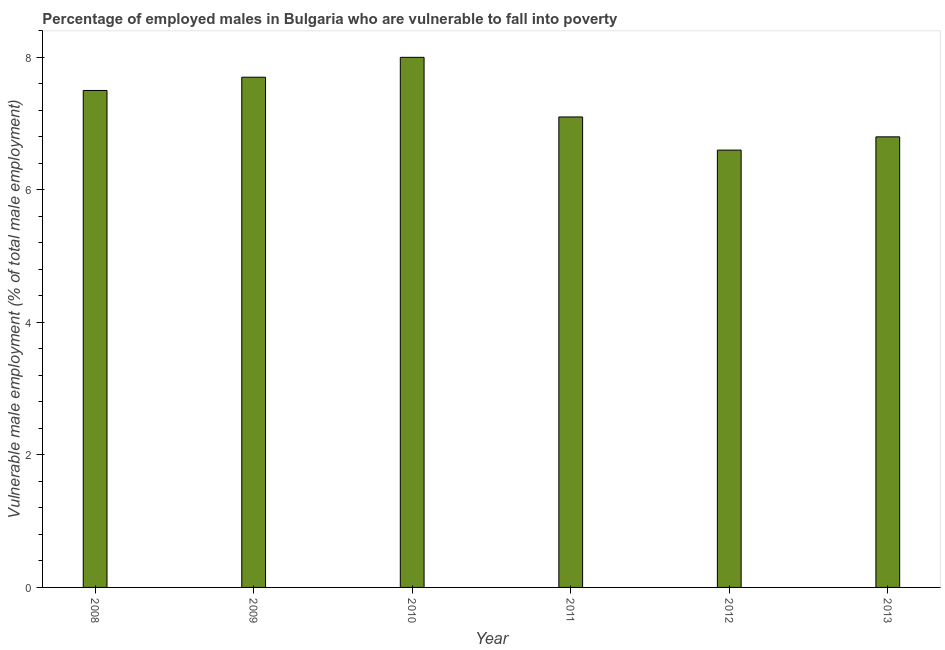Does the graph contain any zero values?
Your answer should be very brief. No. What is the title of the graph?
Your answer should be very brief. Percentage of employed males in Bulgaria who are vulnerable to fall into poverty. What is the label or title of the X-axis?
Offer a very short reply. Year. What is the label or title of the Y-axis?
Your answer should be compact. Vulnerable male employment (% of total male employment). What is the percentage of employed males who are vulnerable to fall into poverty in 2011?
Provide a short and direct response. 7.1. Across all years, what is the maximum percentage of employed males who are vulnerable to fall into poverty?
Ensure brevity in your answer.  8. Across all years, what is the minimum percentage of employed males who are vulnerable to fall into poverty?
Make the answer very short. 6.6. In which year was the percentage of employed males who are vulnerable to fall into poverty maximum?
Your response must be concise. 2010. What is the sum of the percentage of employed males who are vulnerable to fall into poverty?
Offer a very short reply. 43.7. What is the difference between the percentage of employed males who are vulnerable to fall into poverty in 2012 and 2013?
Your answer should be compact. -0.2. What is the average percentage of employed males who are vulnerable to fall into poverty per year?
Ensure brevity in your answer.  7.28. What is the median percentage of employed males who are vulnerable to fall into poverty?
Make the answer very short. 7.3. In how many years, is the percentage of employed males who are vulnerable to fall into poverty greater than 5.2 %?
Keep it short and to the point. 6. What is the ratio of the percentage of employed males who are vulnerable to fall into poverty in 2008 to that in 2012?
Ensure brevity in your answer.  1.14. Is the difference between the percentage of employed males who are vulnerable to fall into poverty in 2011 and 2013 greater than the difference between any two years?
Offer a very short reply. No. Is the sum of the percentage of employed males who are vulnerable to fall into poverty in 2008 and 2011 greater than the maximum percentage of employed males who are vulnerable to fall into poverty across all years?
Make the answer very short. Yes. In how many years, is the percentage of employed males who are vulnerable to fall into poverty greater than the average percentage of employed males who are vulnerable to fall into poverty taken over all years?
Make the answer very short. 3. How many bars are there?
Offer a very short reply. 6. Are all the bars in the graph horizontal?
Give a very brief answer. No. How many years are there in the graph?
Keep it short and to the point. 6. Are the values on the major ticks of Y-axis written in scientific E-notation?
Your answer should be very brief. No. What is the Vulnerable male employment (% of total male employment) of 2009?
Your response must be concise. 7.7. What is the Vulnerable male employment (% of total male employment) of 2011?
Make the answer very short. 7.1. What is the Vulnerable male employment (% of total male employment) in 2012?
Give a very brief answer. 6.6. What is the Vulnerable male employment (% of total male employment) of 2013?
Provide a succinct answer. 6.8. What is the difference between the Vulnerable male employment (% of total male employment) in 2008 and 2009?
Provide a succinct answer. -0.2. What is the difference between the Vulnerable male employment (% of total male employment) in 2008 and 2013?
Give a very brief answer. 0.7. What is the difference between the Vulnerable male employment (% of total male employment) in 2009 and 2011?
Offer a terse response. 0.6. What is the difference between the Vulnerable male employment (% of total male employment) in 2009 and 2013?
Your answer should be very brief. 0.9. What is the difference between the Vulnerable male employment (% of total male employment) in 2010 and 2013?
Provide a succinct answer. 1.2. What is the difference between the Vulnerable male employment (% of total male employment) in 2011 and 2012?
Provide a short and direct response. 0.5. What is the difference between the Vulnerable male employment (% of total male employment) in 2011 and 2013?
Offer a terse response. 0.3. What is the difference between the Vulnerable male employment (% of total male employment) in 2012 and 2013?
Ensure brevity in your answer.  -0.2. What is the ratio of the Vulnerable male employment (% of total male employment) in 2008 to that in 2009?
Offer a terse response. 0.97. What is the ratio of the Vulnerable male employment (% of total male employment) in 2008 to that in 2010?
Provide a short and direct response. 0.94. What is the ratio of the Vulnerable male employment (% of total male employment) in 2008 to that in 2011?
Offer a terse response. 1.06. What is the ratio of the Vulnerable male employment (% of total male employment) in 2008 to that in 2012?
Your answer should be very brief. 1.14. What is the ratio of the Vulnerable male employment (% of total male employment) in 2008 to that in 2013?
Your response must be concise. 1.1. What is the ratio of the Vulnerable male employment (% of total male employment) in 2009 to that in 2010?
Your response must be concise. 0.96. What is the ratio of the Vulnerable male employment (% of total male employment) in 2009 to that in 2011?
Provide a succinct answer. 1.08. What is the ratio of the Vulnerable male employment (% of total male employment) in 2009 to that in 2012?
Keep it short and to the point. 1.17. What is the ratio of the Vulnerable male employment (% of total male employment) in 2009 to that in 2013?
Your answer should be compact. 1.13. What is the ratio of the Vulnerable male employment (% of total male employment) in 2010 to that in 2011?
Keep it short and to the point. 1.13. What is the ratio of the Vulnerable male employment (% of total male employment) in 2010 to that in 2012?
Keep it short and to the point. 1.21. What is the ratio of the Vulnerable male employment (% of total male employment) in 2010 to that in 2013?
Offer a terse response. 1.18. What is the ratio of the Vulnerable male employment (% of total male employment) in 2011 to that in 2012?
Provide a short and direct response. 1.08. What is the ratio of the Vulnerable male employment (% of total male employment) in 2011 to that in 2013?
Make the answer very short. 1.04. 